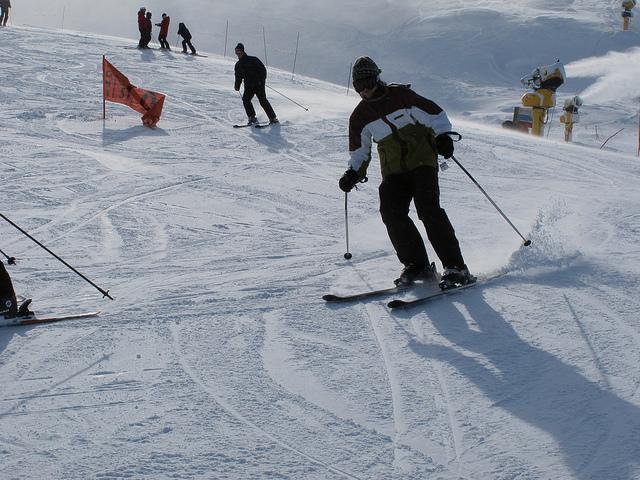What is this activity for?
From the following four choices, select the correct answer to address the question.
Options: Racing, photo taking, practice, leisure. Racing. 